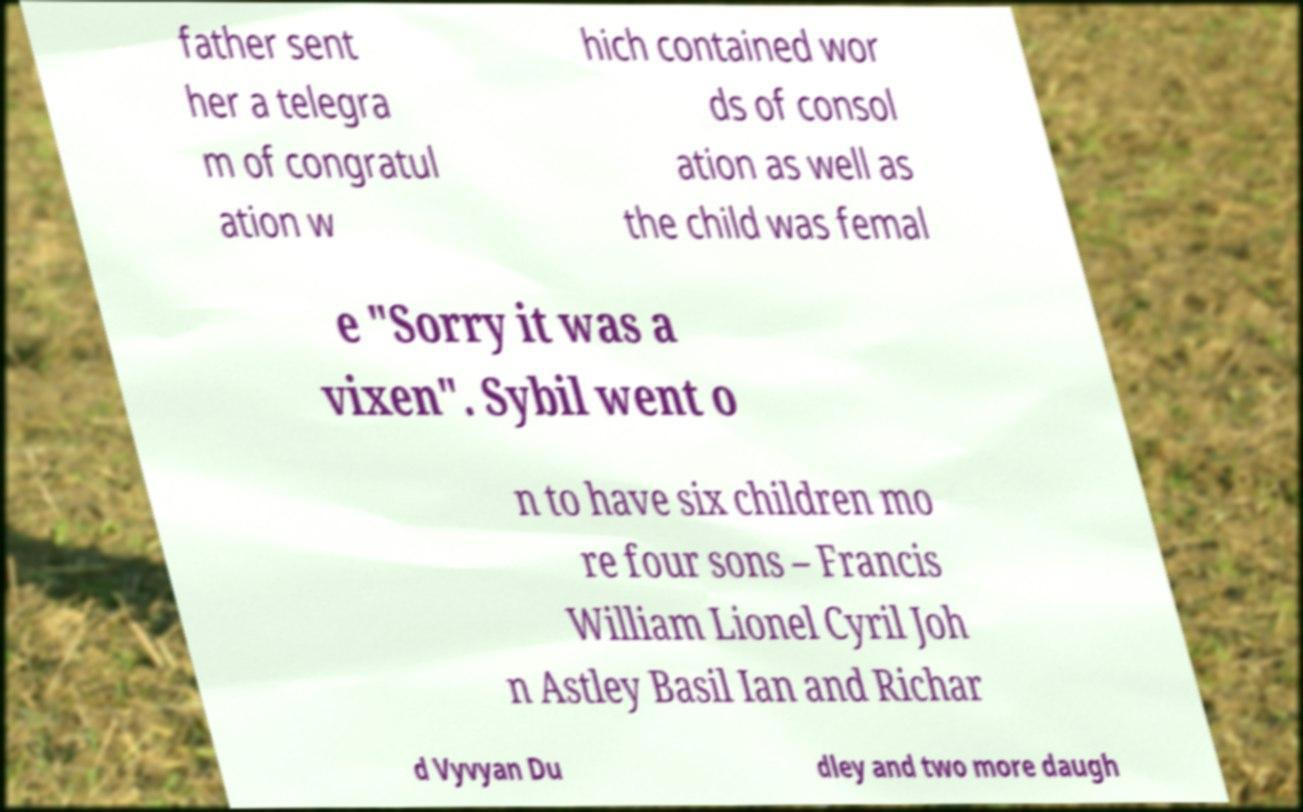Could you assist in decoding the text presented in this image and type it out clearly? father sent her a telegra m of congratul ation w hich contained wor ds of consol ation as well as the child was femal e "Sorry it was a vixen". Sybil went o n to have six children mo re four sons – Francis William Lionel Cyril Joh n Astley Basil Ian and Richar d Vyvyan Du dley and two more daugh 